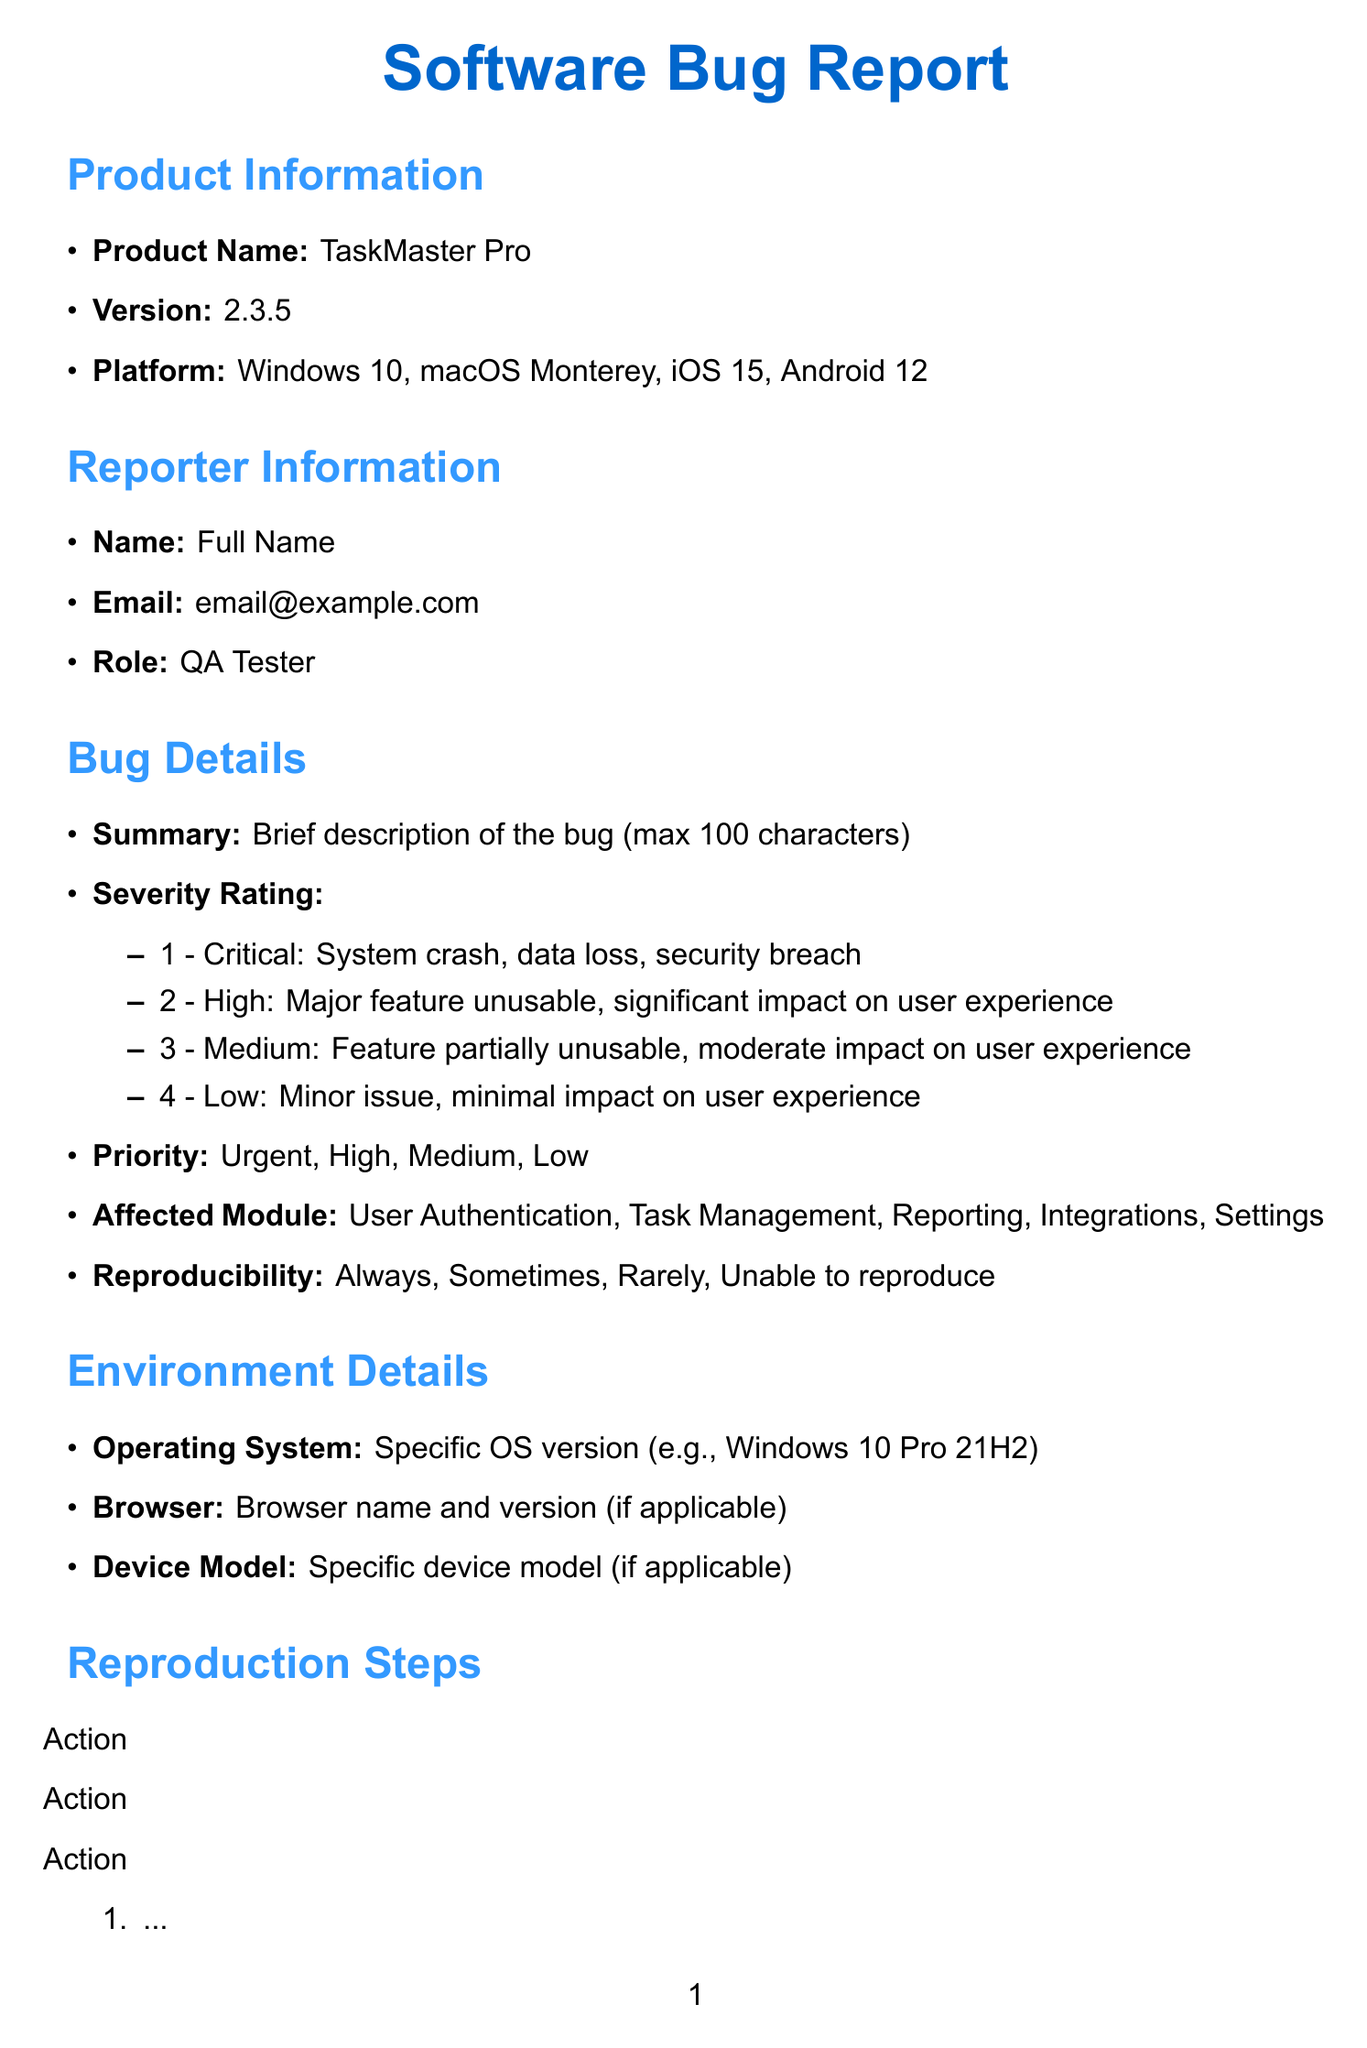What is the product name? The product name is mentioned in the product information section of the document.
Answer: TaskMaster Pro What is the version of the product? The version of the product is provided in the product information section.
Answer: 2.3.5 What is the highest severity rating? The severity ratings are listed in the bug details section, and the highest one is identified.
Answer: Critical Which module is affected? The affected modules are listed in the bug details section.
Answer: User Authentication How many reproducibility options are available? The reproducibility options are listed in the bug details section.
Answer: Four What should happen when following the reproduction steps? The expected result describes what should occur during the reproduction process.
Answer: Describe what should happen when following the reproduction steps What is the estimated fix time? The estimated time required to fix the bug is found in the product owner section.
Answer: Estimated time required to fix the bug Is this bug a release blocker? The status of whether this bug blocks the next release is specified in the document.
Answer: Yes/No Has this bug been reported by a customer? The customer escalation status is indicated in the document.
Answer: Yes/No 